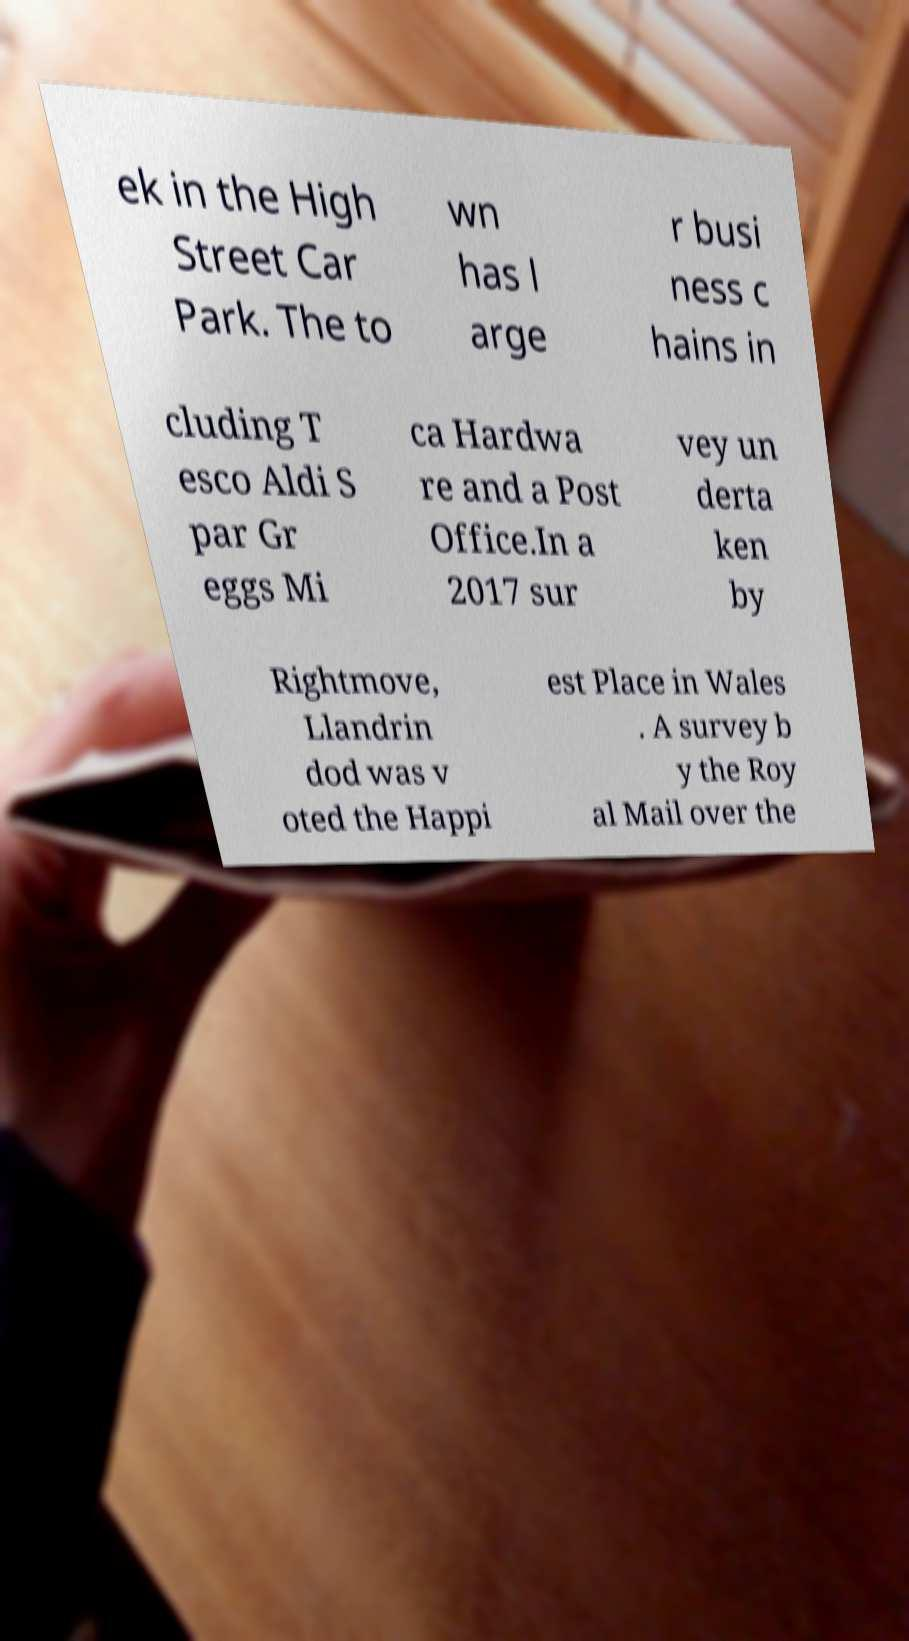Can you read and provide the text displayed in the image?This photo seems to have some interesting text. Can you extract and type it out for me? ek in the High Street Car Park. The to wn has l arge r busi ness c hains in cluding T esco Aldi S par Gr eggs Mi ca Hardwa re and a Post Office.In a 2017 sur vey un derta ken by Rightmove, Llandrin dod was v oted the Happi est Place in Wales . A survey b y the Roy al Mail over the 